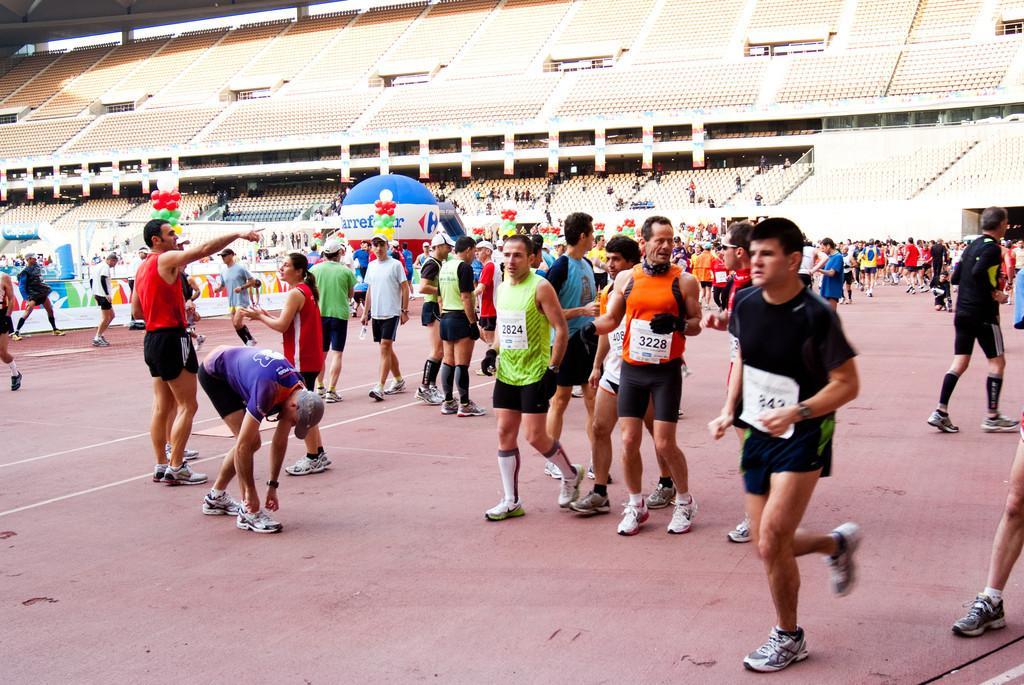In one or two sentences, can you explain what this image depicts? In this picture we can see a group of people on the ground and in the background we can see a shed. 